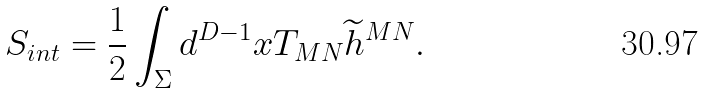Convert formula to latex. <formula><loc_0><loc_0><loc_500><loc_500>S _ { i n t } = \frac { 1 } { 2 } \int _ { \Sigma } d ^ { D - 1 } x T _ { M N } \widetilde { h } ^ { M N } .</formula> 